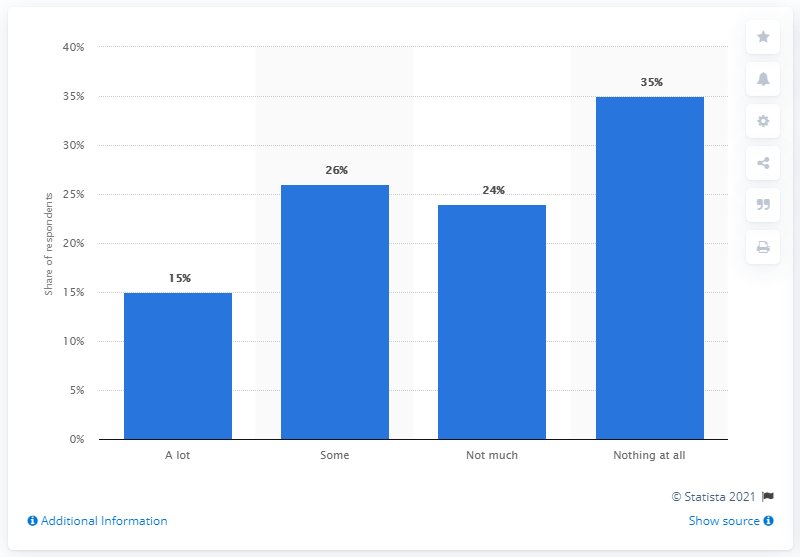List a handful of essential elements in this visual. According to a survey, a significant portion of adults in the United States reported having been exposed to a lot of information about Disney+. Specifically, 15% of the respondents indicated that they have received a lot of information about the streaming service. 